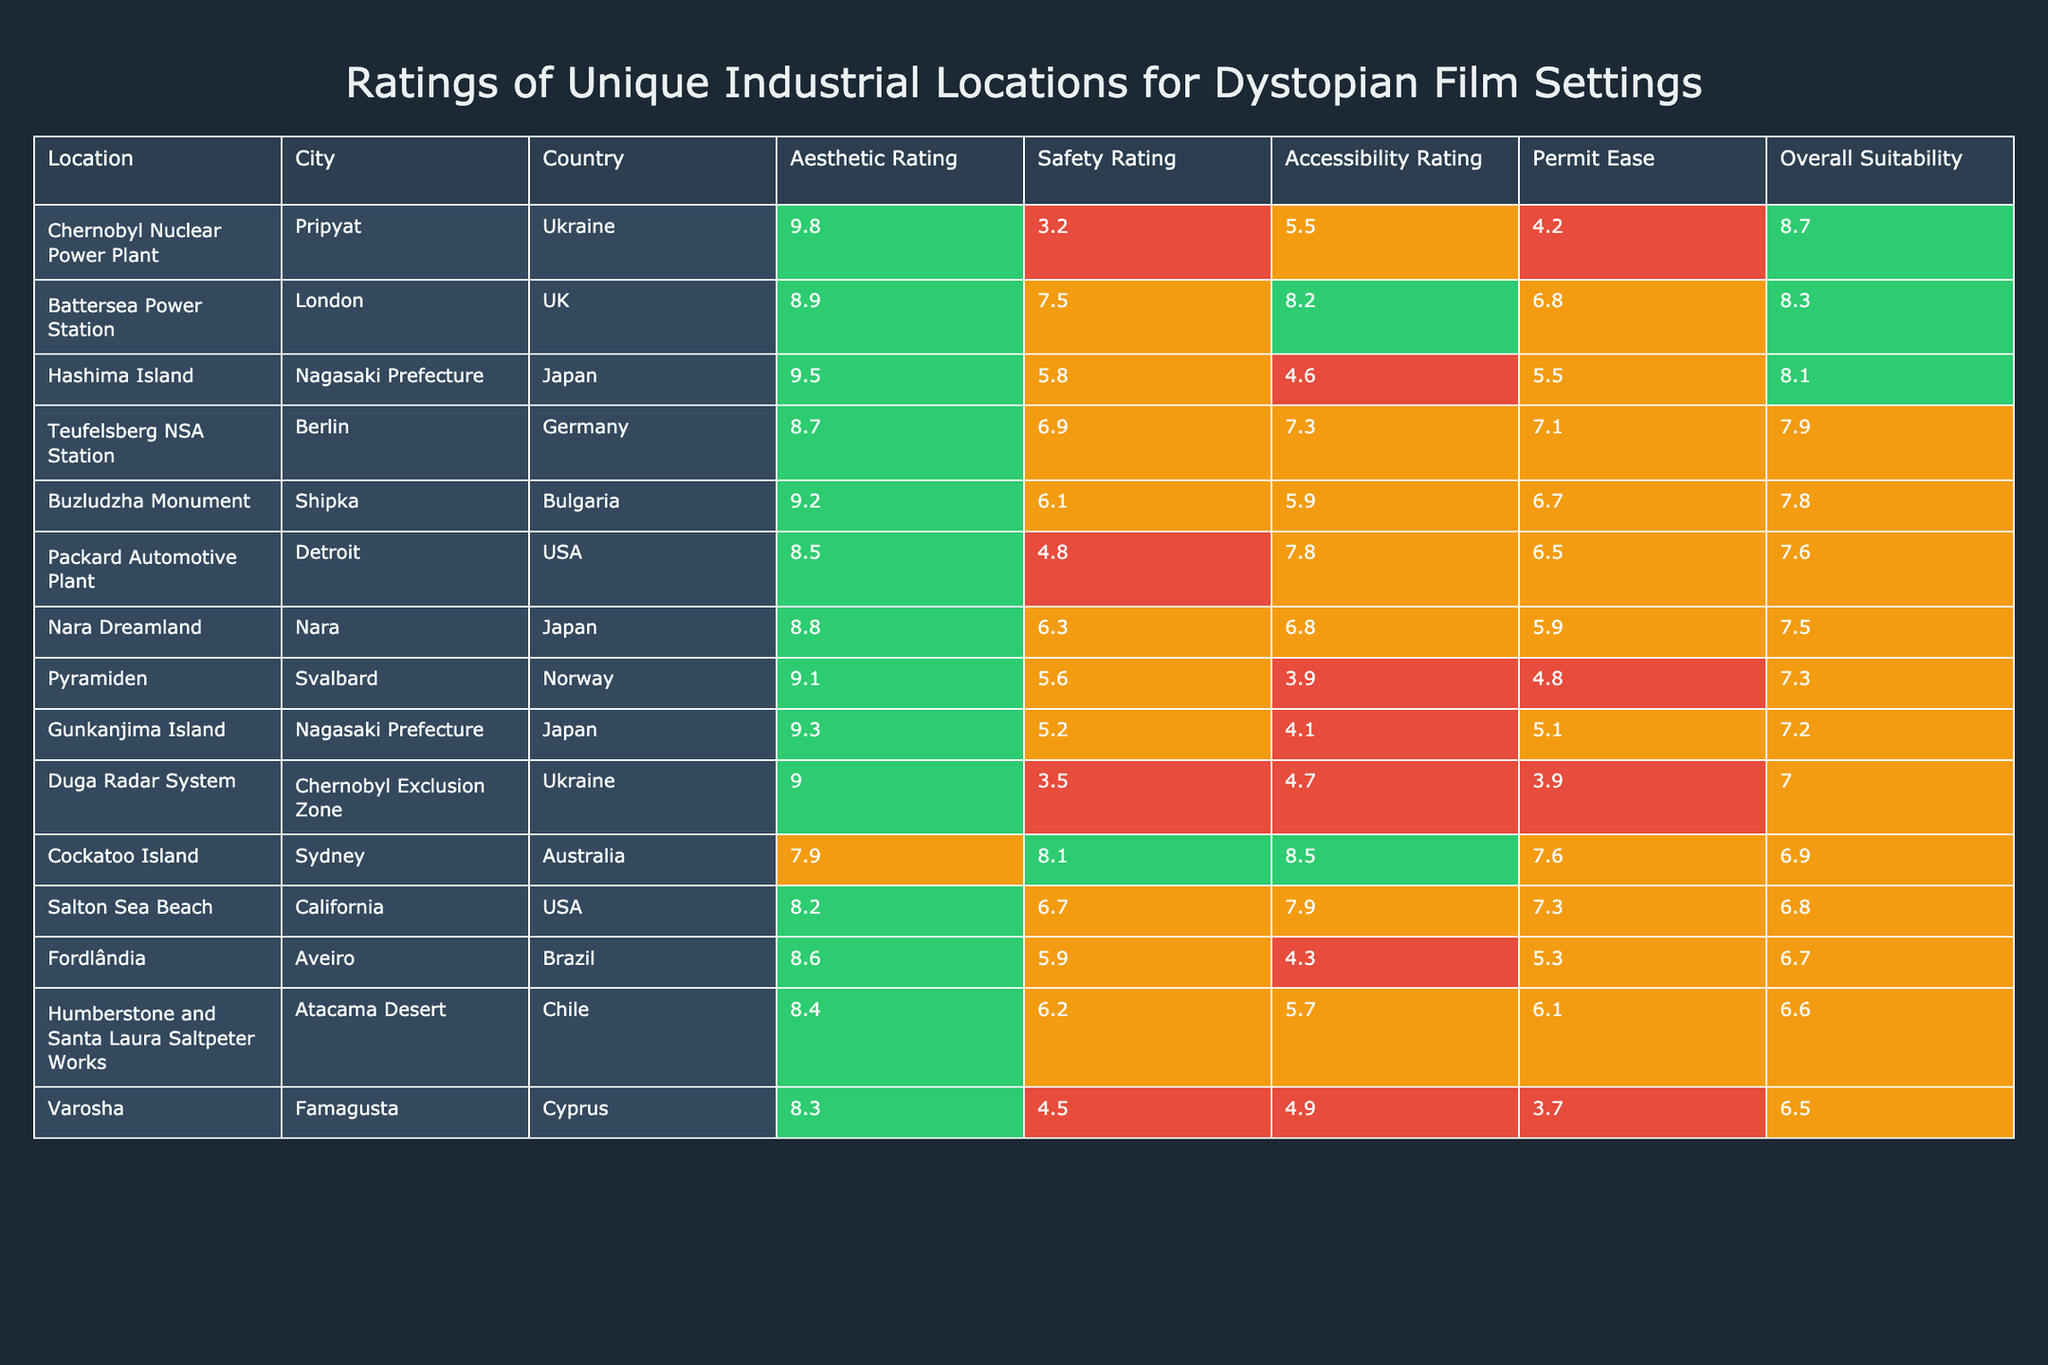What is the highest Aesthetic Rating among the locations? The highest Aesthetic Rating in the table is 9.8, which is associated with the Chernobyl Nuclear Power Plant.
Answer: 9.8 Which location has the lowest Safety Rating? The location with the lowest Safety Rating is the Chernobyl Nuclear Power Plant, with a rating of 3.2.
Answer: Chernobyl Nuclear Power Plant Is the Permitting Ease rating for the Battersea Power Station greater than 5? The Permitting Ease rating for the Battersea Power Station is 6.8, which is greater than 5.
Answer: Yes What is the Overall Suitability of Hashima Island compared to the Pyramiden? Hashima Island has an Overall Suitability rating of 8.1, while Pyramiden has a rating of 7.3; thus, Hashima Island is more suitable.
Answer: Hashima Island is more suitable Calculate the average Accessibility Rating for all locations. To find the average, sum the Accessibility Ratings (5.5 + 8.2 + 4.6 + 7.3 + 5.9 + 7.8 + 6.8 + 3.9 + 4.1 + 4.7 + 8.5 + 7.9 + 4.3 + 5.7 + 4.9) = 86.1 and divide by the total number of locations (15), resulting in an average of 5.74.
Answer: 5.74 Which location has a higher combination of Aesthetic and Overall Suitability ratings, Buzludzha Monument or Teufelsberg NSA Station? Buzludzha Monument has an Aesthetic Rating of 9.2 and an Overall Suitability of 7.8, for a total of 17; Teufelsberg NSA Station has an Aesthetic Rating of 8.7 and an Overall Suitability of 7.9, totaling 16.6. Therefore, Buzludzha Monument has the higher combination.
Answer: Buzludzha Monument Are most locations rated above 7 in Overall Suitability? By counting the Overall Suitability values greater than 7, we see that there are 9 locations rated above 7 out of 15 total locations, indicating a majority.
Answer: Yes What is the difference in Aesthetic Rating between the highest rated and lowest rated locations? The highest Aesthetic Rating is 9.8 (Chernobyl Nuclear Power Plant) and the lowest is 7.9 (Cockatoo Island), so the difference is 9.8 - 7.9 = 1.9.
Answer: 1.9 Which city has the highest rated location in terms of Accessibility Rating? The city with the highest rated location in Accessibility is Sydney (Cockatoo Island) with a rating of 8.5.
Answer: Sydney List the locations that are rated below 7 in either Safety or Overall Suitability. The locations rated below 7 in Safety are Chernobyl Nuclear Power Plant, Packard Automotive Plant, and Varosha. In terms of Overall Suitability, the locations below 7 include Packard Automotive Plant, Duga Radar System, Cockatoo Island, Salton Sea Beach, Fordlândia, Humberstone and Santa Laura Saltpeter Works, and Varosha. Thus, the combined list includes Chernobyl Nuclear Power Plant, Packard Automotive Plant, Duga Radar System, Cockatoo Island, Salton Sea Beach, Fordlândia, Humberstone and Santa Laura Saltpeter Works, and Varosha.
Answer: Chernobyl Nuclear Power Plant, Packard Automotive Plant, Duga Radar System, Cockatoo Island, Salton Sea Beach, Fordlândia, Humberstone and Santa Laura Saltpeter Works, Varosha 